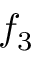<formula> <loc_0><loc_0><loc_500><loc_500>f _ { 3 }</formula> 